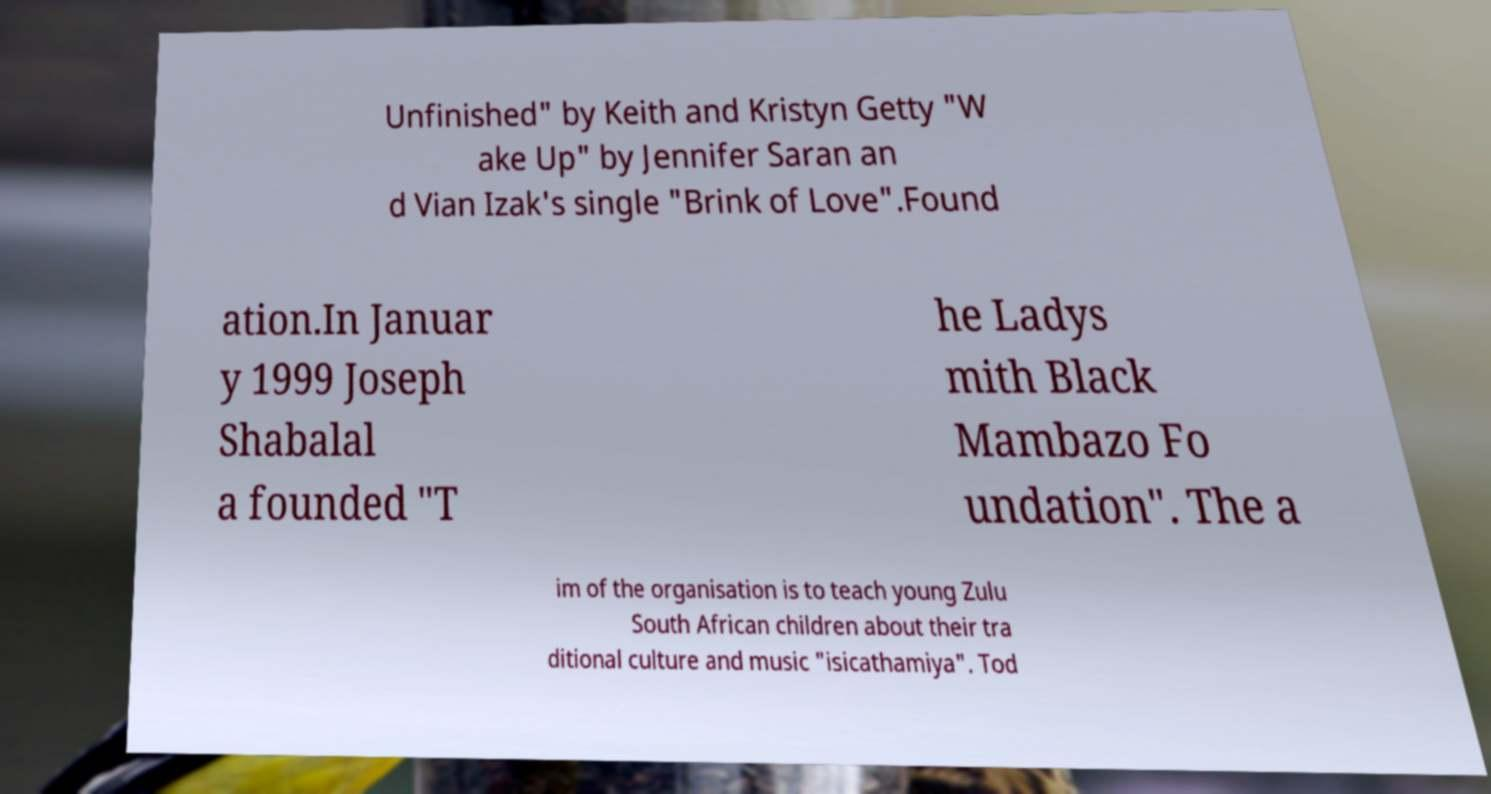There's text embedded in this image that I need extracted. Can you transcribe it verbatim? Unfinished" by Keith and Kristyn Getty "W ake Up" by Jennifer Saran an d Vian Izak's single "Brink of Love".Found ation.In Januar y 1999 Joseph Shabalal a founded "T he Ladys mith Black Mambazo Fo undation". The a im of the organisation is to teach young Zulu South African children about their tra ditional culture and music "isicathamiya". Tod 